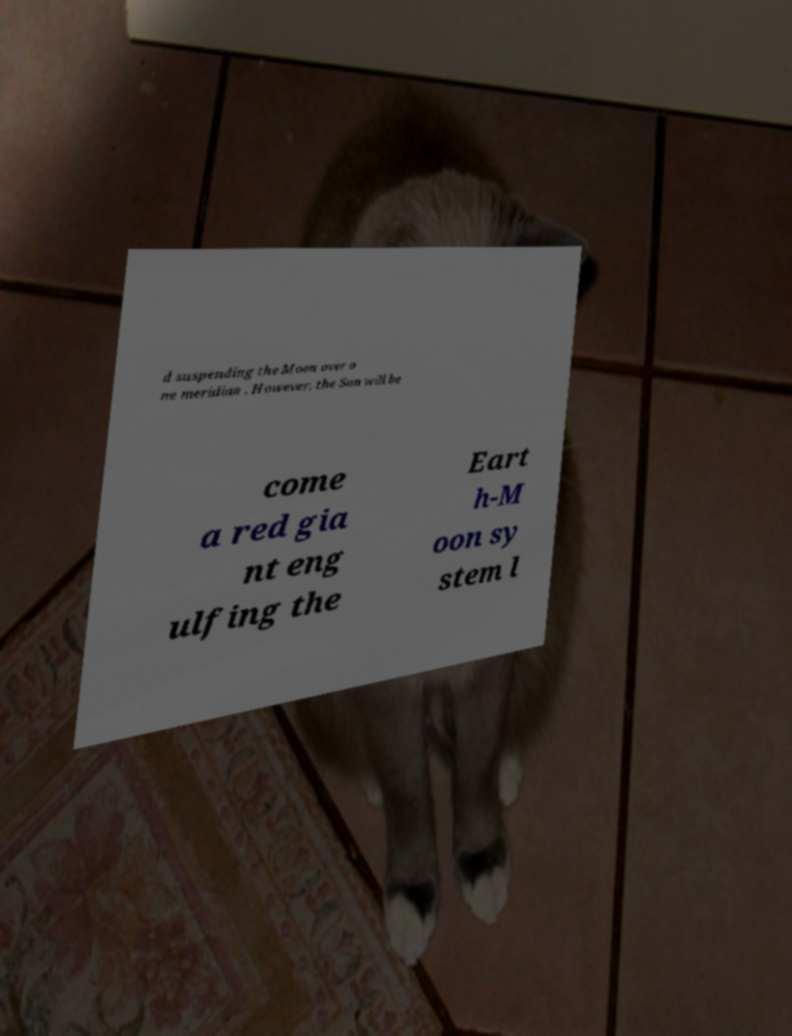Please read and relay the text visible in this image. What does it say? d suspending the Moon over o ne meridian . However, the Sun will be come a red gia nt eng ulfing the Eart h-M oon sy stem l 